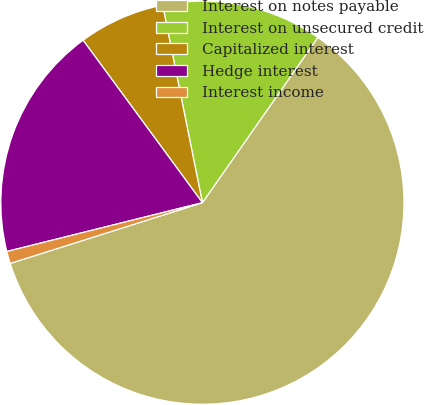<chart> <loc_0><loc_0><loc_500><loc_500><pie_chart><fcel>Interest on notes payable<fcel>Interest on unsecured credit<fcel>Capitalized interest<fcel>Hedge interest<fcel>Interest income<nl><fcel>60.42%<fcel>12.87%<fcel>6.92%<fcel>18.81%<fcel>0.98%<nl></chart> 